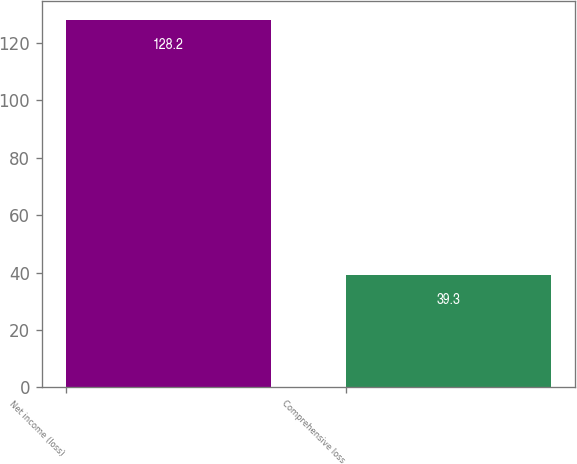Convert chart to OTSL. <chart><loc_0><loc_0><loc_500><loc_500><bar_chart><fcel>Net income (loss)<fcel>Comprehensive loss<nl><fcel>128.2<fcel>39.3<nl></chart> 